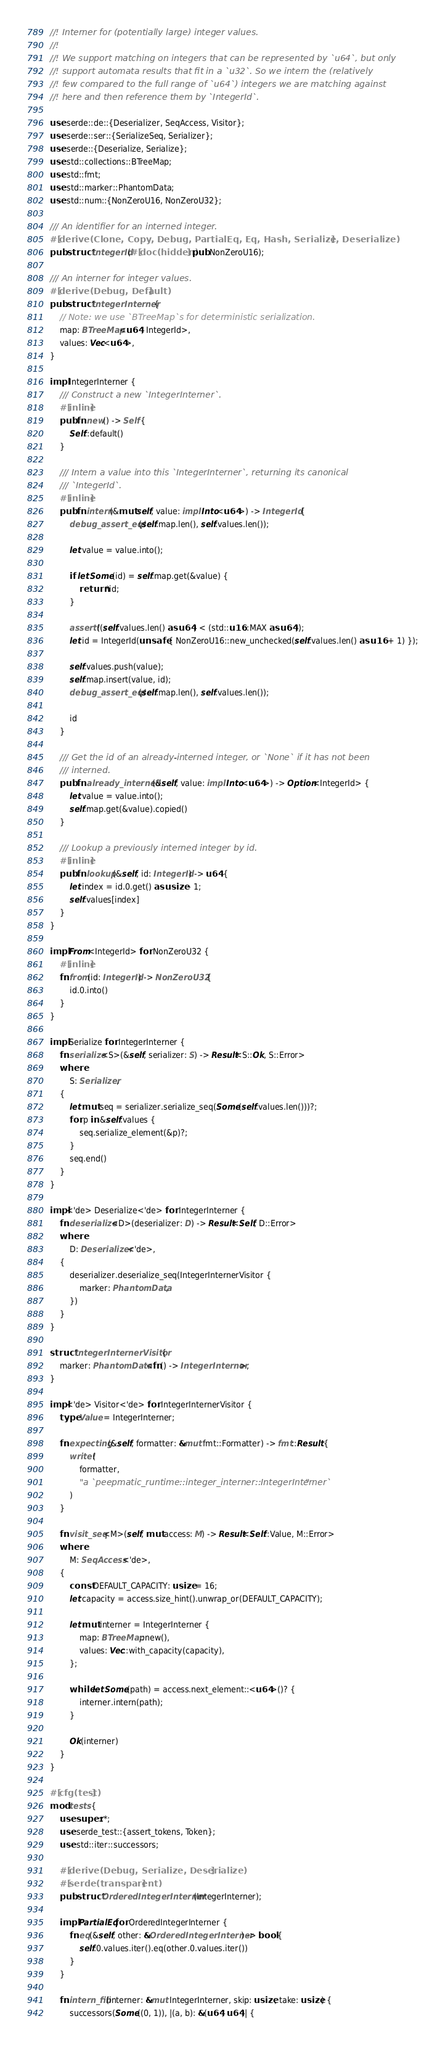<code> <loc_0><loc_0><loc_500><loc_500><_Rust_>//! Interner for (potentially large) integer values.
//!
//! We support matching on integers that can be represented by `u64`, but only
//! support automata results that fit in a `u32`. So we intern the (relatively
//! few compared to the full range of `u64`) integers we are matching against
//! here and then reference them by `IntegerId`.

use serde::de::{Deserializer, SeqAccess, Visitor};
use serde::ser::{SerializeSeq, Serializer};
use serde::{Deserialize, Serialize};
use std::collections::BTreeMap;
use std::fmt;
use std::marker::PhantomData;
use std::num::{NonZeroU16, NonZeroU32};

/// An identifier for an interned integer.
#[derive(Clone, Copy, Debug, PartialEq, Eq, Hash, Serialize, Deserialize)]
pub struct IntegerId(#[doc(hidden)] pub NonZeroU16);

/// An interner for integer values.
#[derive(Debug, Default)]
pub struct IntegerInterner {
    // Note: we use `BTreeMap`s for deterministic serialization.
    map: BTreeMap<u64, IntegerId>,
    values: Vec<u64>,
}

impl IntegerInterner {
    /// Construct a new `IntegerInterner`.
    #[inline]
    pub fn new() -> Self {
        Self::default()
    }

    /// Intern a value into this `IntegerInterner`, returning its canonical
    /// `IntegerId`.
    #[inline]
    pub fn intern(&mut self, value: impl Into<u64>) -> IntegerId {
        debug_assert_eq!(self.map.len(), self.values.len());

        let value = value.into();

        if let Some(id) = self.map.get(&value) {
            return *id;
        }

        assert!((self.values.len() as u64) < (std::u16::MAX as u64));
        let id = IntegerId(unsafe { NonZeroU16::new_unchecked(self.values.len() as u16 + 1) });

        self.values.push(value);
        self.map.insert(value, id);
        debug_assert_eq!(self.map.len(), self.values.len());

        id
    }

    /// Get the id of an already-interned integer, or `None` if it has not been
    /// interned.
    pub fn already_interned(&self, value: impl Into<u64>) -> Option<IntegerId> {
        let value = value.into();
        self.map.get(&value).copied()
    }

    /// Lookup a previously interned integer by id.
    #[inline]
    pub fn lookup(&self, id: IntegerId) -> u64 {
        let index = id.0.get() as usize - 1;
        self.values[index]
    }
}

impl From<IntegerId> for NonZeroU32 {
    #[inline]
    fn from(id: IntegerId) -> NonZeroU32 {
        id.0.into()
    }
}

impl Serialize for IntegerInterner {
    fn serialize<S>(&self, serializer: S) -> Result<S::Ok, S::Error>
    where
        S: Serializer,
    {
        let mut seq = serializer.serialize_seq(Some(self.values.len()))?;
        for p in &self.values {
            seq.serialize_element(&p)?;
        }
        seq.end()
    }
}

impl<'de> Deserialize<'de> for IntegerInterner {
    fn deserialize<D>(deserializer: D) -> Result<Self, D::Error>
    where
        D: Deserializer<'de>,
    {
        deserializer.deserialize_seq(IntegerInternerVisitor {
            marker: PhantomData,
        })
    }
}

struct IntegerInternerVisitor {
    marker: PhantomData<fn() -> IntegerInterner>,
}

impl<'de> Visitor<'de> for IntegerInternerVisitor {
    type Value = IntegerInterner;

    fn expecting(&self, formatter: &mut fmt::Formatter) -> fmt::Result {
        write!(
            formatter,
            "a `peepmatic_runtime::integer_interner::IntegerInterner`"
        )
    }

    fn visit_seq<M>(self, mut access: M) -> Result<Self::Value, M::Error>
    where
        M: SeqAccess<'de>,
    {
        const DEFAULT_CAPACITY: usize = 16;
        let capacity = access.size_hint().unwrap_or(DEFAULT_CAPACITY);

        let mut interner = IntegerInterner {
            map: BTreeMap::new(),
            values: Vec::with_capacity(capacity),
        };

        while let Some(path) = access.next_element::<u64>()? {
            interner.intern(path);
        }

        Ok(interner)
    }
}

#[cfg(test)]
mod tests {
    use super::*;
    use serde_test::{assert_tokens, Token};
    use std::iter::successors;

    #[derive(Debug, Serialize, Deserialize)]
    #[serde(transparent)]
    pub struct OrderedIntegerInterner(IntegerInterner);

    impl PartialEq for OrderedIntegerInterner {
        fn eq(&self, other: &OrderedIntegerInterner) -> bool {
            self.0.values.iter().eq(other.0.values.iter())
        }
    }

    fn intern_fib(interner: &mut IntegerInterner, skip: usize, take: usize) {
        successors(Some((0, 1)), |(a, b): &(u64, u64)| {</code> 